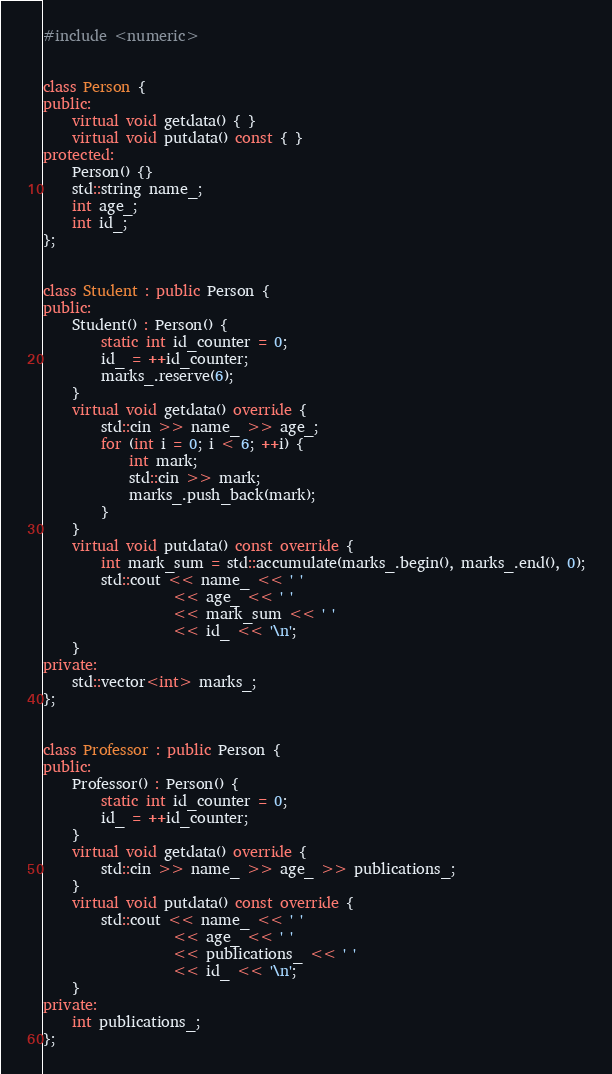Convert code to text. <code><loc_0><loc_0><loc_500><loc_500><_C++_>
#include <numeric>


class Person {
public:
    virtual void getdata() { }
    virtual void putdata() const { }
protected:
    Person() {}
    std::string name_;
    int age_;
    int id_;
};


class Student : public Person {
public:
    Student() : Person() {
        static int id_counter = 0;
        id_ = ++id_counter;
        marks_.reserve(6);
    }
    virtual void getdata() override {
        std::cin >> name_ >> age_;
        for (int i = 0; i < 6; ++i) {
            int mark;
            std::cin >> mark;
            marks_.push_back(mark);
        }
    }
    virtual void putdata() const override {
        int mark_sum = std::accumulate(marks_.begin(), marks_.end(), 0);
        std::cout << name_ << ' '
                  << age_ << ' '
                  << mark_sum << ' '
                  << id_ << '\n';
    }
private:
    std::vector<int> marks_;
};


class Professor : public Person {
public:
    Professor() : Person() {
        static int id_counter = 0;
        id_ = ++id_counter;
    }
    virtual void getdata() override {
        std::cin >> name_ >> age_ >> publications_;
    }
    virtual void putdata() const override {
        std::cout << name_ << ' '
                  << age_ << ' '
                  << publications_ << ' '
                  << id_ << '\n';
    }
private:
    int publications_;
};




</code> 